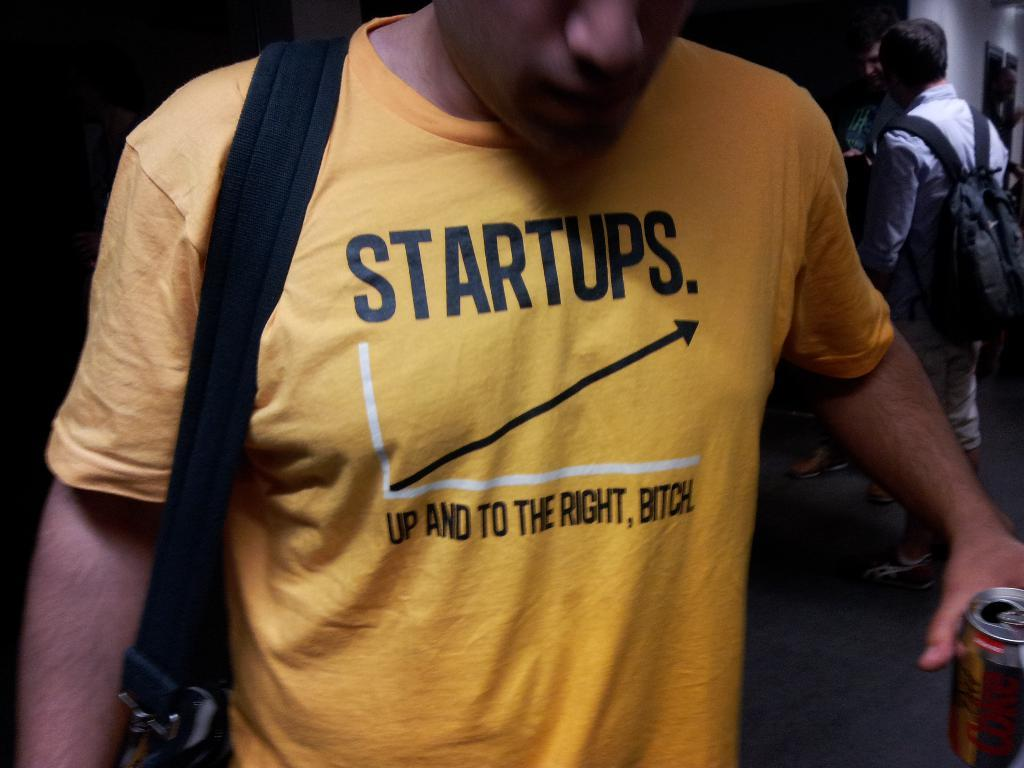<image>
Write a terse but informative summary of the picture. Man wearing a yellow shirt that says Startups on it. 